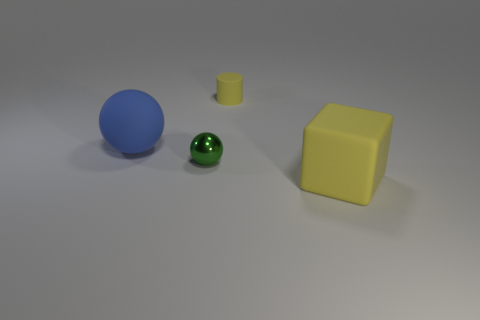Add 2 big red objects. How many objects exist? 6 Subtract all cylinders. How many objects are left? 3 Subtract all large green blocks. Subtract all small yellow rubber things. How many objects are left? 3 Add 4 large objects. How many large objects are left? 6 Add 1 big gray spheres. How many big gray spheres exist? 1 Subtract 0 purple cubes. How many objects are left? 4 